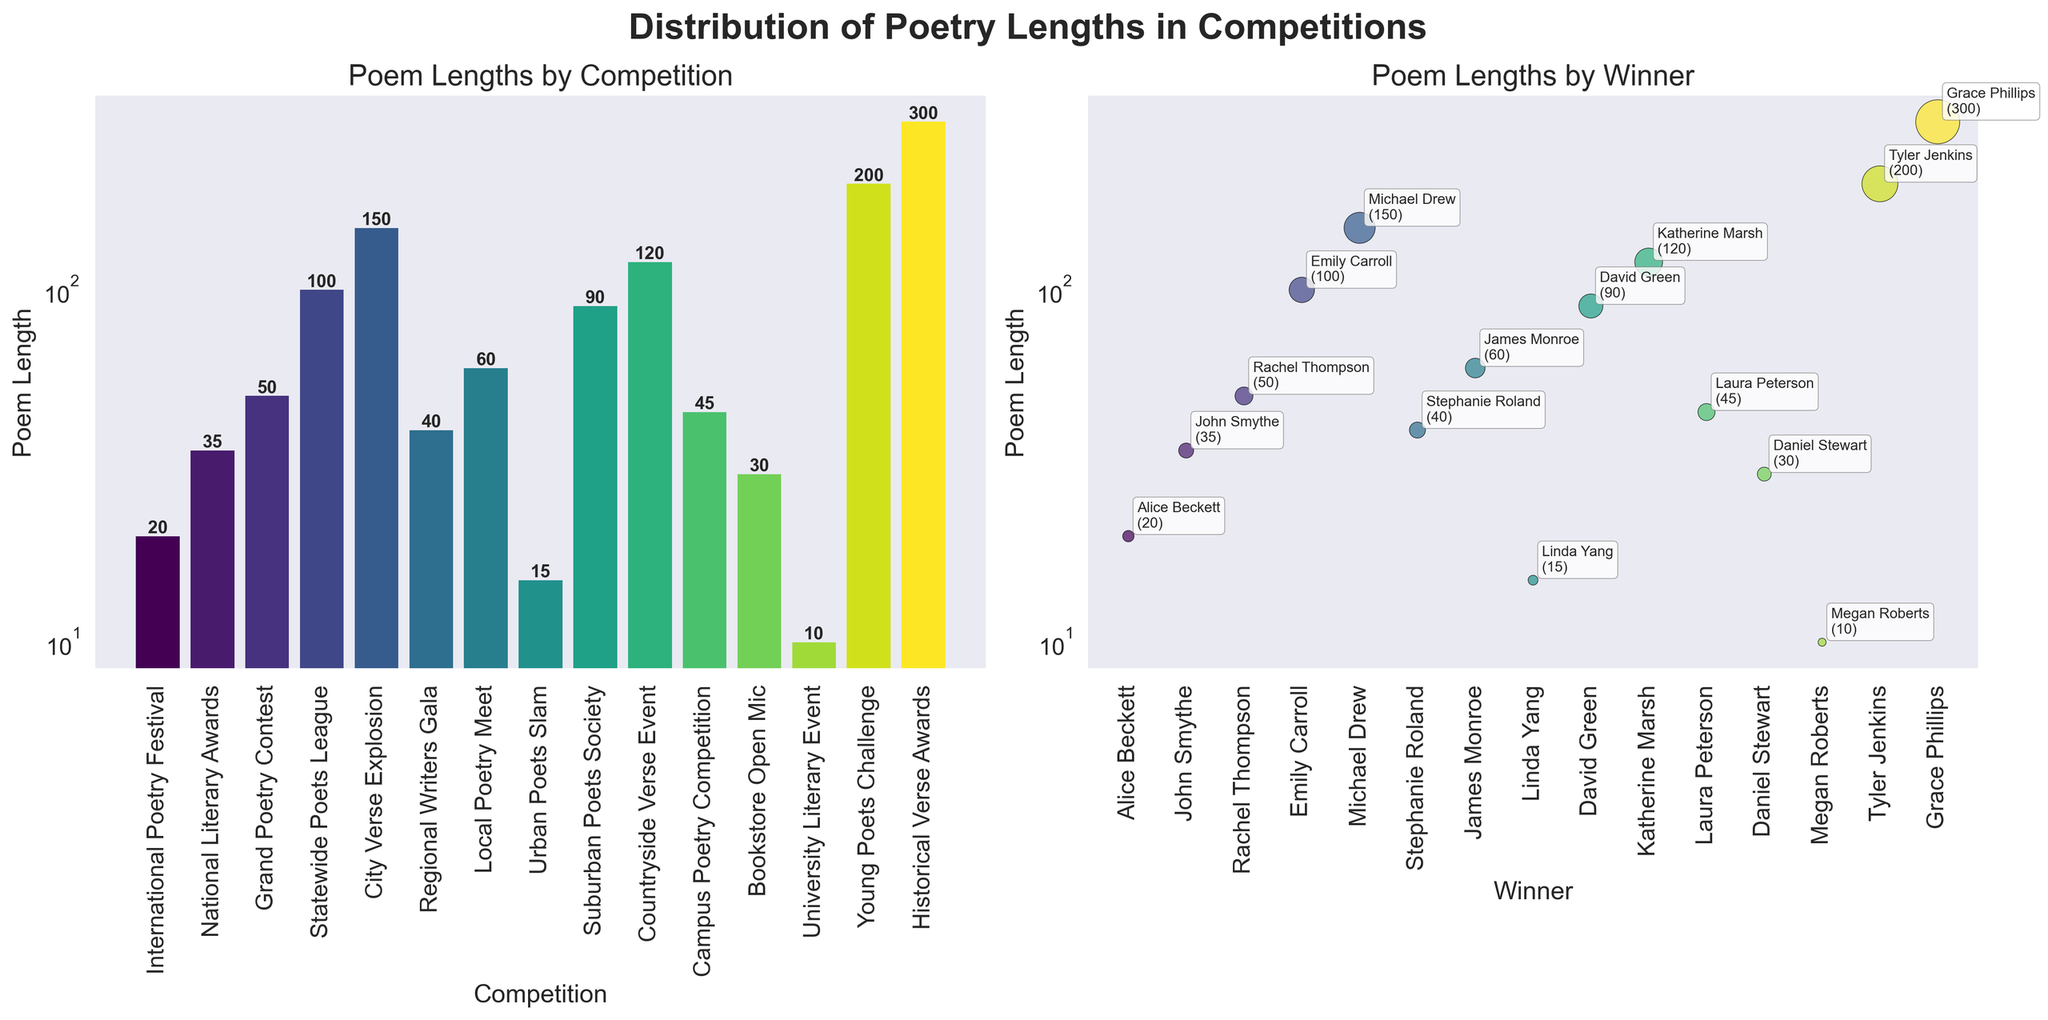What's the title of the figure? The title of the figure is located at the top and reads "Distribution of Poetry Lengths in Competitions".
Answer: Distribution of Poetry Lengths in Competitions How many competitions are shown in the bar plot? There are individual bars in the bar plot, each representing a different competition. Counting these bars gives the total number of competitions.
Answer: 15 Which competition had the poem with the longest length, and what was that length? By looking at the highest bar in the bar plot, we can identify which competition had the longest poem. The label on this bar indicates the length.
Answer: Historical Verse Awards, 300 What competition had the shortest poem, and what was its length? Locating the shortest bar in the bar plot and reading its label will give us the competition with the shortest poem along with the length.
Answer: University Literary Event, 10 Which winner had the poem of 200 lines? In the scatter plot, locate the point with a y-axis value of 200. The winner associated with this point, displayed as an annotation, will provide the answer.
Answer: Tyler Jenkins What's the total length of poems for competitions with poem lengths more than 100 lines? Competitions with poem lengths of more than 100 lines are given: Emily Carroll (100), Michael Drew (150), Katherine Marsh (120), Tyler Jenkins (200), and Grace Phillips (300). Summing these values gives the total.
Answer: 870 Which winner's poem length is closest to 50 lines? In the scatter plot, find the point nearest to the y-axis value of 50 and identify the associated winner from the annotations.
Answer: Rachel Thompson How many winners had their poem lengths annotated as text in the scatter plot? The scatter plot annotates each winner's point. Counting these annotations will give the total number of annotated winners.
Answer: 15 In the scatter plot, who had a poem length of 60 lines? Find the annotation labeled as 60 in the scatter plot and identify the associated winner.
Answer: James Monroe Which competition had a poem length of 90 lines? Refer to the bar plot, find the bar labeled with the length 90 and identify the corresponding competition.
Answer: Suburban Poets Society 